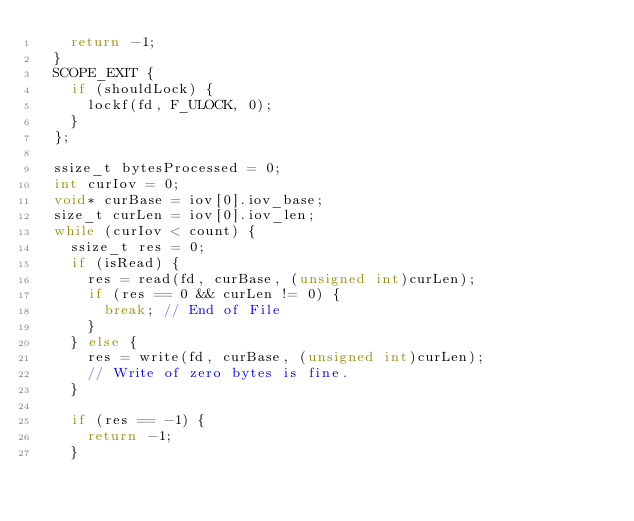<code> <loc_0><loc_0><loc_500><loc_500><_C++_>    return -1;
  }
  SCOPE_EXIT {
    if (shouldLock) {
      lockf(fd, F_ULOCK, 0);
    }
  };

  ssize_t bytesProcessed = 0;
  int curIov = 0;
  void* curBase = iov[0].iov_base;
  size_t curLen = iov[0].iov_len;
  while (curIov < count) {
    ssize_t res = 0;
    if (isRead) {
      res = read(fd, curBase, (unsigned int)curLen);
      if (res == 0 && curLen != 0) {
        break; // End of File
      }
    } else {
      res = write(fd, curBase, (unsigned int)curLen);
      // Write of zero bytes is fine.
    }

    if (res == -1) {
      return -1;
    }
</code> 